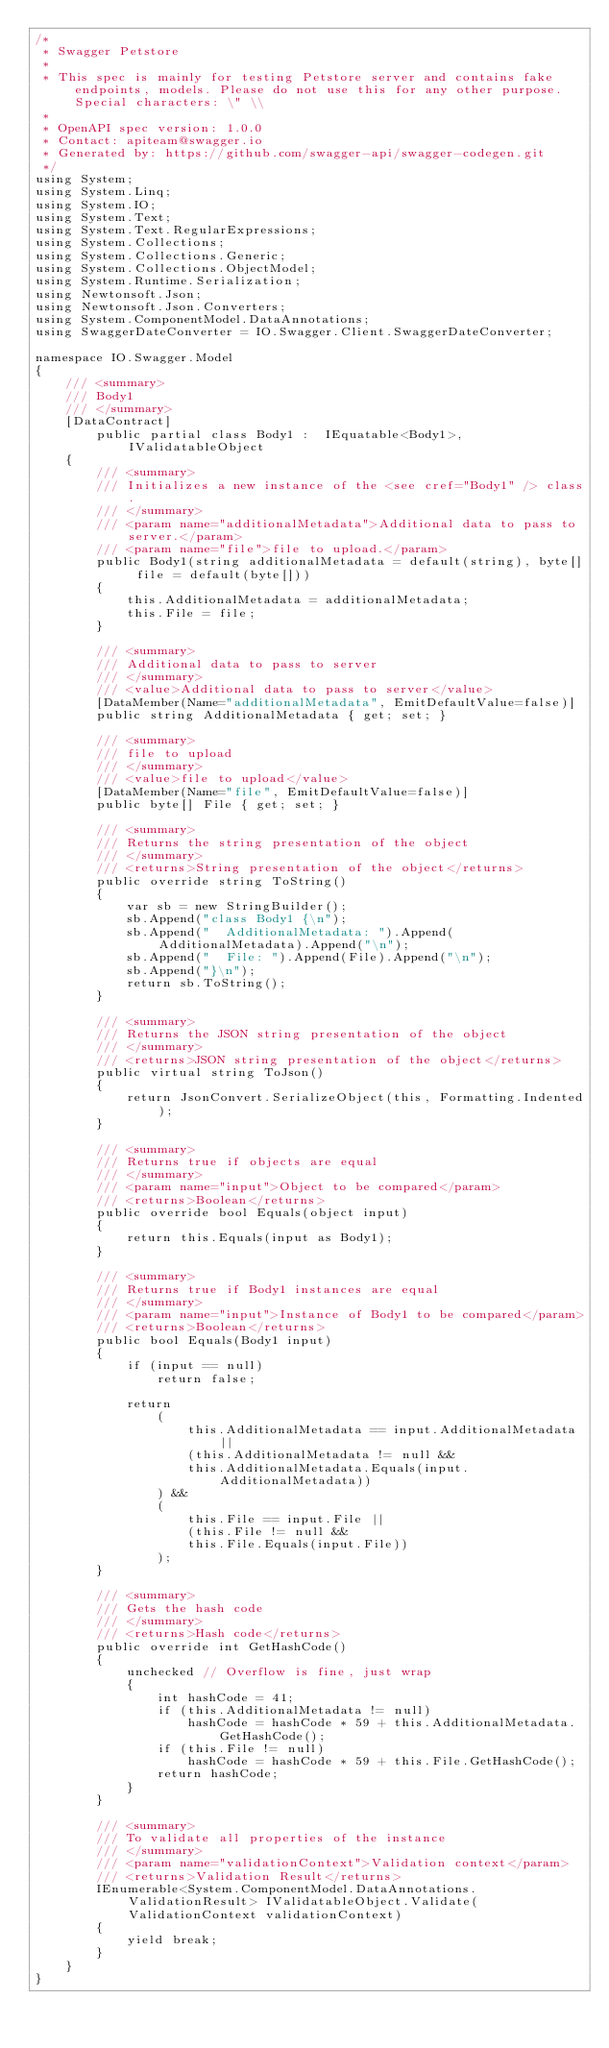Convert code to text. <code><loc_0><loc_0><loc_500><loc_500><_C#_>/* 
 * Swagger Petstore
 *
 * This spec is mainly for testing Petstore server and contains fake endpoints, models. Please do not use this for any other purpose. Special characters: \" \\
 *
 * OpenAPI spec version: 1.0.0
 * Contact: apiteam@swagger.io
 * Generated by: https://github.com/swagger-api/swagger-codegen.git
 */
using System;
using System.Linq;
using System.IO;
using System.Text;
using System.Text.RegularExpressions;
using System.Collections;
using System.Collections.Generic;
using System.Collections.ObjectModel;
using System.Runtime.Serialization;
using Newtonsoft.Json;
using Newtonsoft.Json.Converters;
using System.ComponentModel.DataAnnotations;
using SwaggerDateConverter = IO.Swagger.Client.SwaggerDateConverter;

namespace IO.Swagger.Model
{
    /// <summary>
    /// Body1
    /// </summary>
    [DataContract]
        public partial class Body1 :  IEquatable<Body1>, IValidatableObject
    {
        /// <summary>
        /// Initializes a new instance of the <see cref="Body1" /> class.
        /// </summary>
        /// <param name="additionalMetadata">Additional data to pass to server.</param>
        /// <param name="file">file to upload.</param>
        public Body1(string additionalMetadata = default(string), byte[] file = default(byte[]))
        {
            this.AdditionalMetadata = additionalMetadata;
            this.File = file;
        }
        
        /// <summary>
        /// Additional data to pass to server
        /// </summary>
        /// <value>Additional data to pass to server</value>
        [DataMember(Name="additionalMetadata", EmitDefaultValue=false)]
        public string AdditionalMetadata { get; set; }

        /// <summary>
        /// file to upload
        /// </summary>
        /// <value>file to upload</value>
        [DataMember(Name="file", EmitDefaultValue=false)]
        public byte[] File { get; set; }

        /// <summary>
        /// Returns the string presentation of the object
        /// </summary>
        /// <returns>String presentation of the object</returns>
        public override string ToString()
        {
            var sb = new StringBuilder();
            sb.Append("class Body1 {\n");
            sb.Append("  AdditionalMetadata: ").Append(AdditionalMetadata).Append("\n");
            sb.Append("  File: ").Append(File).Append("\n");
            sb.Append("}\n");
            return sb.ToString();
        }
  
        /// <summary>
        /// Returns the JSON string presentation of the object
        /// </summary>
        /// <returns>JSON string presentation of the object</returns>
        public virtual string ToJson()
        {
            return JsonConvert.SerializeObject(this, Formatting.Indented);
        }

        /// <summary>
        /// Returns true if objects are equal
        /// </summary>
        /// <param name="input">Object to be compared</param>
        /// <returns>Boolean</returns>
        public override bool Equals(object input)
        {
            return this.Equals(input as Body1);
        }

        /// <summary>
        /// Returns true if Body1 instances are equal
        /// </summary>
        /// <param name="input">Instance of Body1 to be compared</param>
        /// <returns>Boolean</returns>
        public bool Equals(Body1 input)
        {
            if (input == null)
                return false;

            return 
                (
                    this.AdditionalMetadata == input.AdditionalMetadata ||
                    (this.AdditionalMetadata != null &&
                    this.AdditionalMetadata.Equals(input.AdditionalMetadata))
                ) && 
                (
                    this.File == input.File ||
                    (this.File != null &&
                    this.File.Equals(input.File))
                );
        }

        /// <summary>
        /// Gets the hash code
        /// </summary>
        /// <returns>Hash code</returns>
        public override int GetHashCode()
        {
            unchecked // Overflow is fine, just wrap
            {
                int hashCode = 41;
                if (this.AdditionalMetadata != null)
                    hashCode = hashCode * 59 + this.AdditionalMetadata.GetHashCode();
                if (this.File != null)
                    hashCode = hashCode * 59 + this.File.GetHashCode();
                return hashCode;
            }
        }

        /// <summary>
        /// To validate all properties of the instance
        /// </summary>
        /// <param name="validationContext">Validation context</param>
        /// <returns>Validation Result</returns>
        IEnumerable<System.ComponentModel.DataAnnotations.ValidationResult> IValidatableObject.Validate(ValidationContext validationContext)
        {
            yield break;
        }
    }
}
</code> 